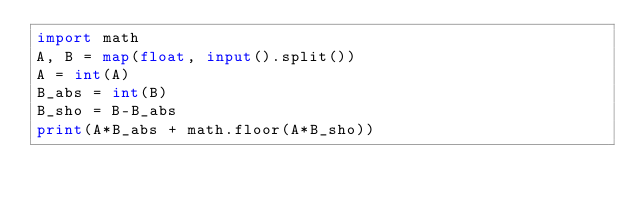<code> <loc_0><loc_0><loc_500><loc_500><_Python_>import math
A, B = map(float, input().split())
A = int(A)
B_abs = int(B)
B_sho = B-B_abs
print(A*B_abs + math.floor(A*B_sho))</code> 